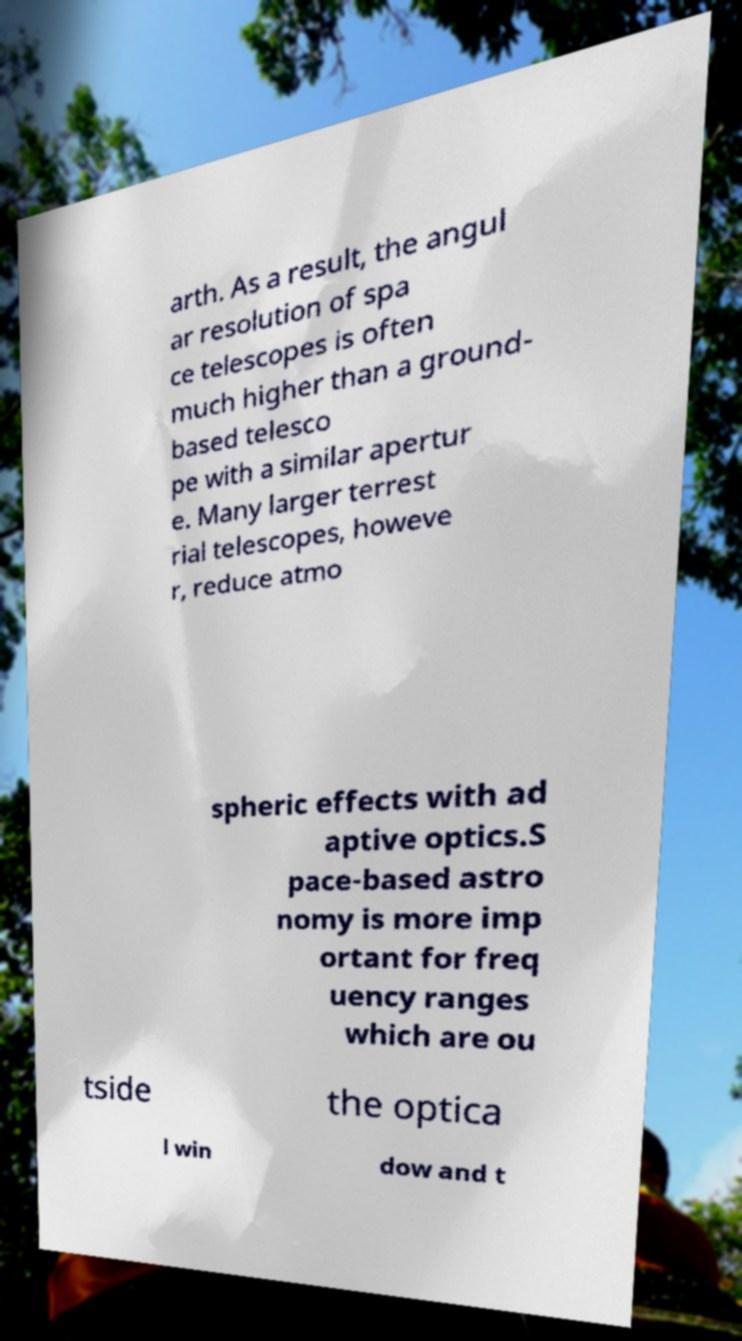Can you accurately transcribe the text from the provided image for me? arth. As a result, the angul ar resolution of spa ce telescopes is often much higher than a ground- based telesco pe with a similar apertur e. Many larger terrest rial telescopes, howeve r, reduce atmo spheric effects with ad aptive optics.S pace-based astro nomy is more imp ortant for freq uency ranges which are ou tside the optica l win dow and t 